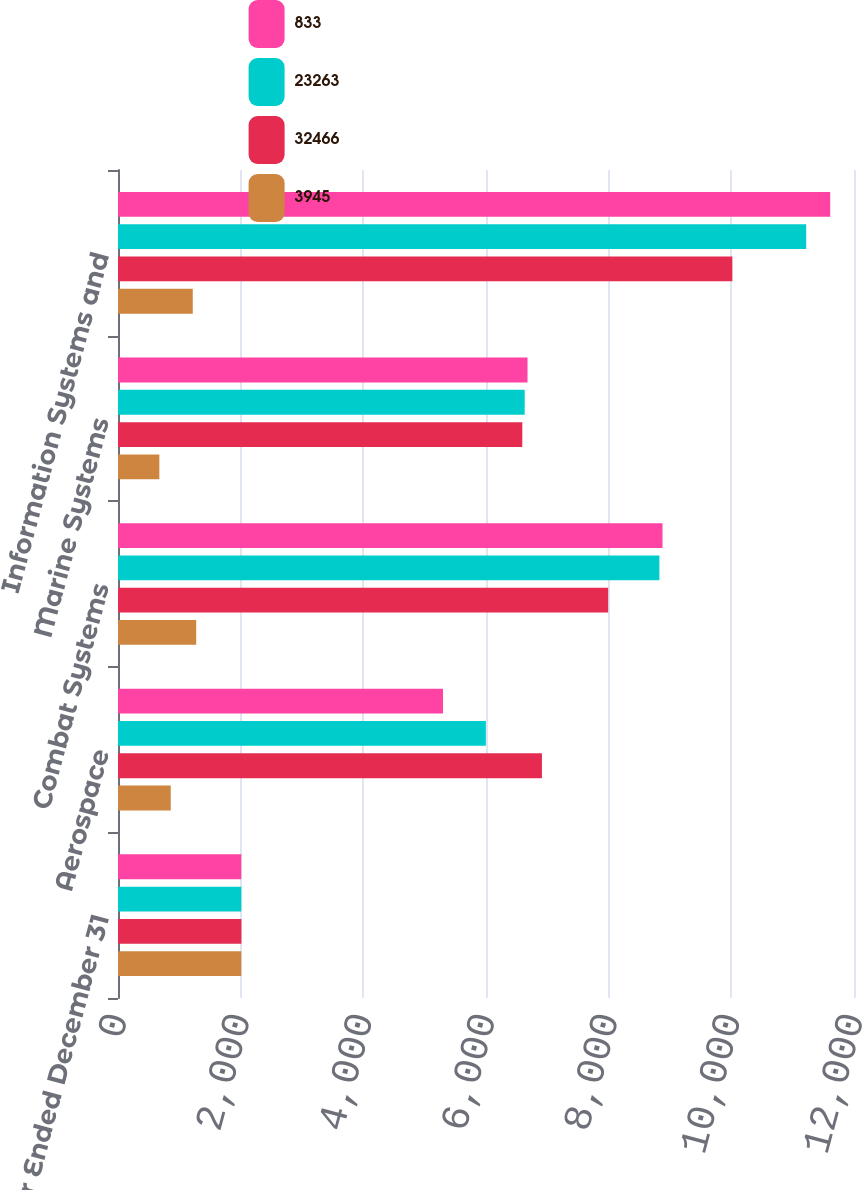<chart> <loc_0><loc_0><loc_500><loc_500><stacked_bar_chart><ecel><fcel>Year Ended December 31<fcel>Aerospace<fcel>Combat Systems<fcel>Marine Systems<fcel>Information Systems and<nl><fcel>833<fcel>2010<fcel>5299<fcel>8878<fcel>6677<fcel>11612<nl><fcel>23263<fcel>2011<fcel>5998<fcel>8827<fcel>6631<fcel>11221<nl><fcel>32466<fcel>2012<fcel>6912<fcel>7992<fcel>6592<fcel>10017<nl><fcel>3945<fcel>2010<fcel>860<fcel>1275<fcel>674<fcel>1219<nl></chart> 